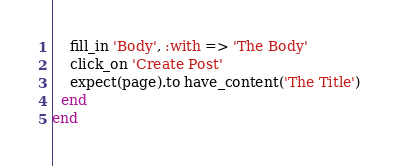<code> <loc_0><loc_0><loc_500><loc_500><_Ruby_>    fill_in 'Body', :with => 'The Body'
    click_on 'Create Post'
    expect(page).to have_content('The Title')
  end
end
</code> 